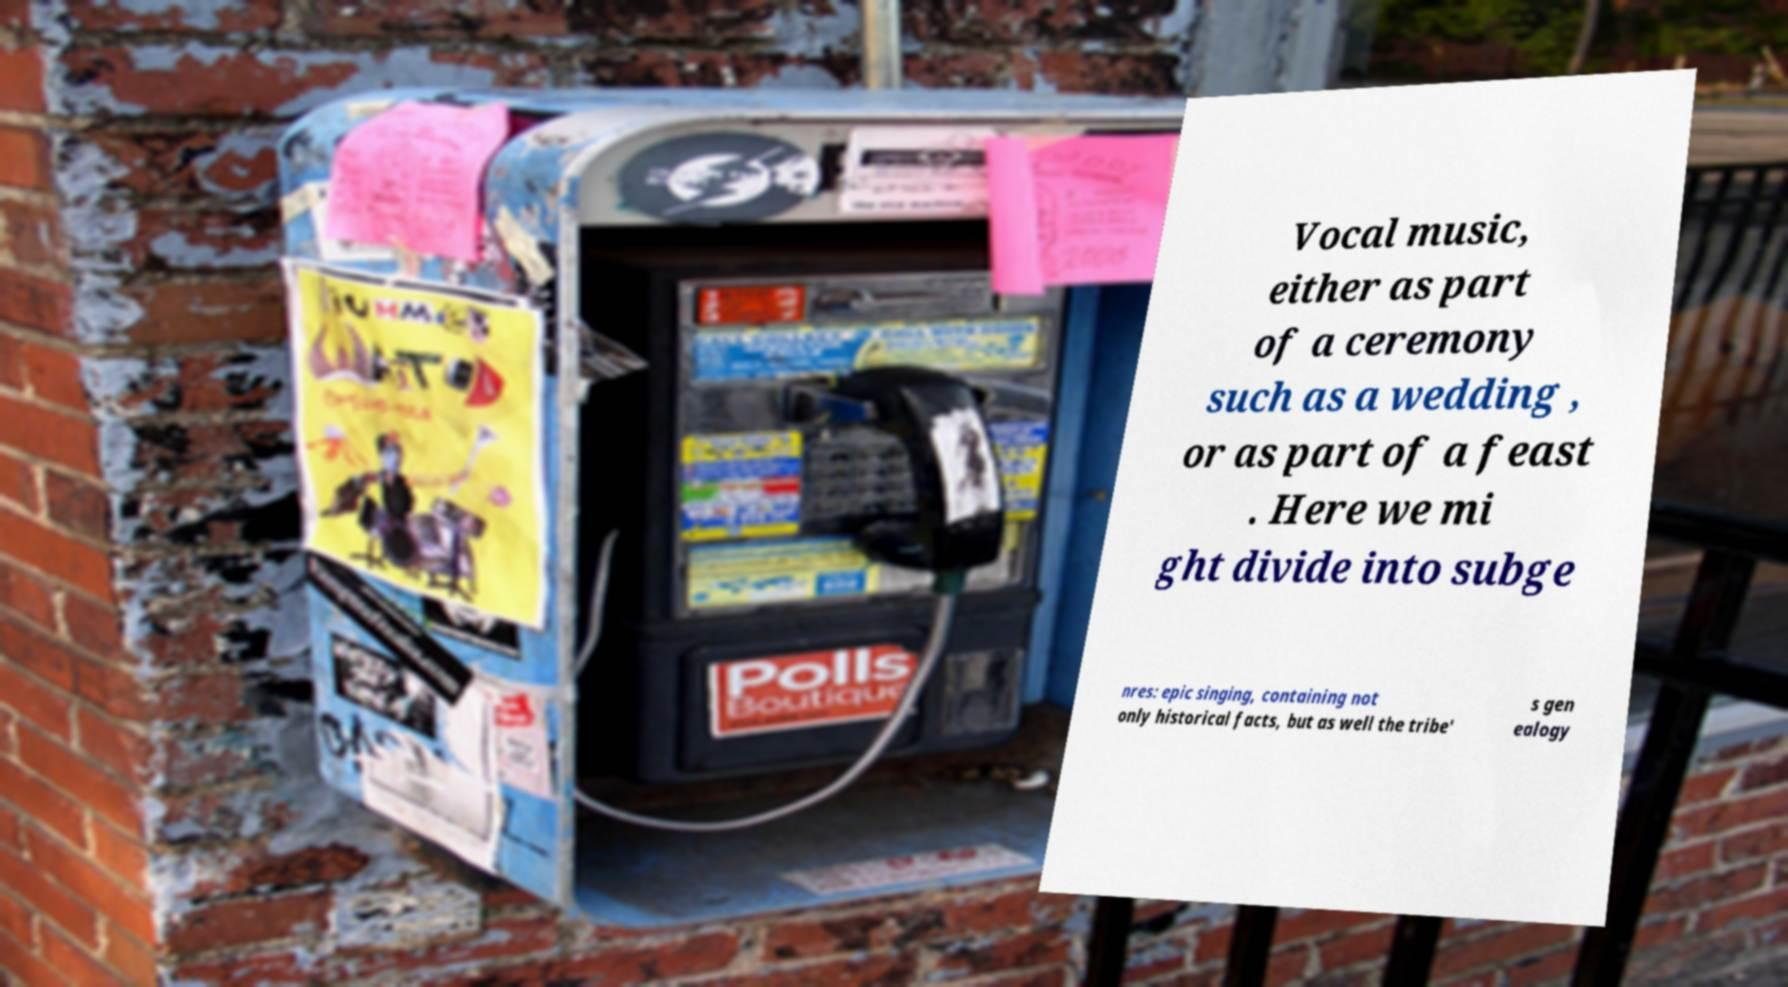There's text embedded in this image that I need extracted. Can you transcribe it verbatim? Vocal music, either as part of a ceremony such as a wedding , or as part of a feast . Here we mi ght divide into subge nres: epic singing, containing not only historical facts, but as well the tribe' s gen ealogy 